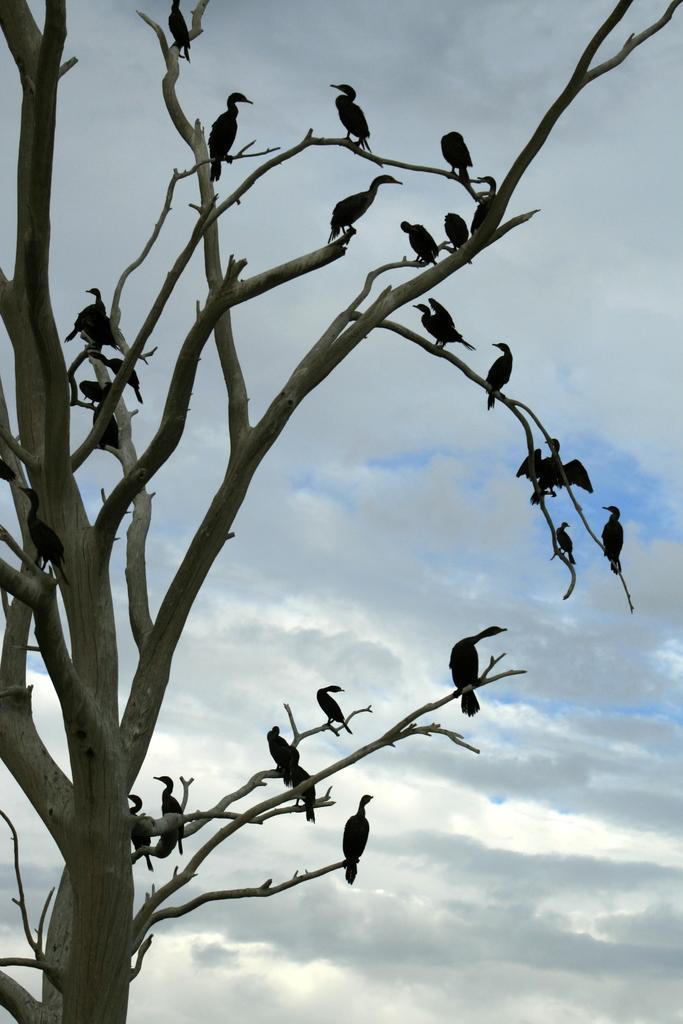In one or two sentences, can you explain what this image depicts? In this picture I can see birds on the branches of a tree, and in the background there is the sky. 